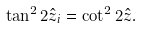Convert formula to latex. <formula><loc_0><loc_0><loc_500><loc_500>\tan ^ { 2 } 2 \hat { z } _ { i } = \cot ^ { 2 } 2 \hat { z } .</formula> 